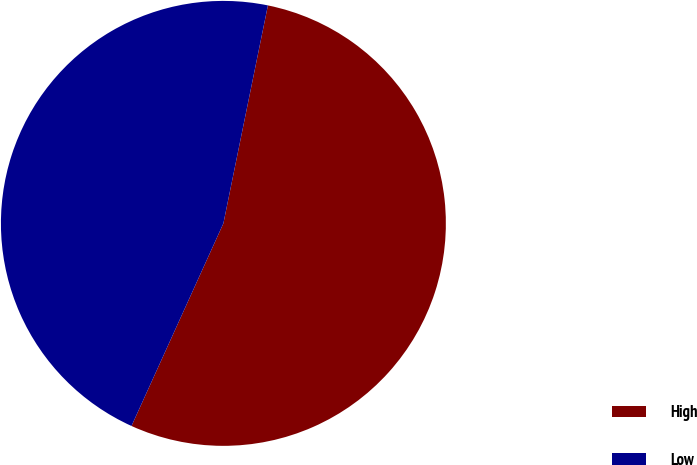Convert chart. <chart><loc_0><loc_0><loc_500><loc_500><pie_chart><fcel>High<fcel>Low<nl><fcel>53.57%<fcel>46.43%<nl></chart> 